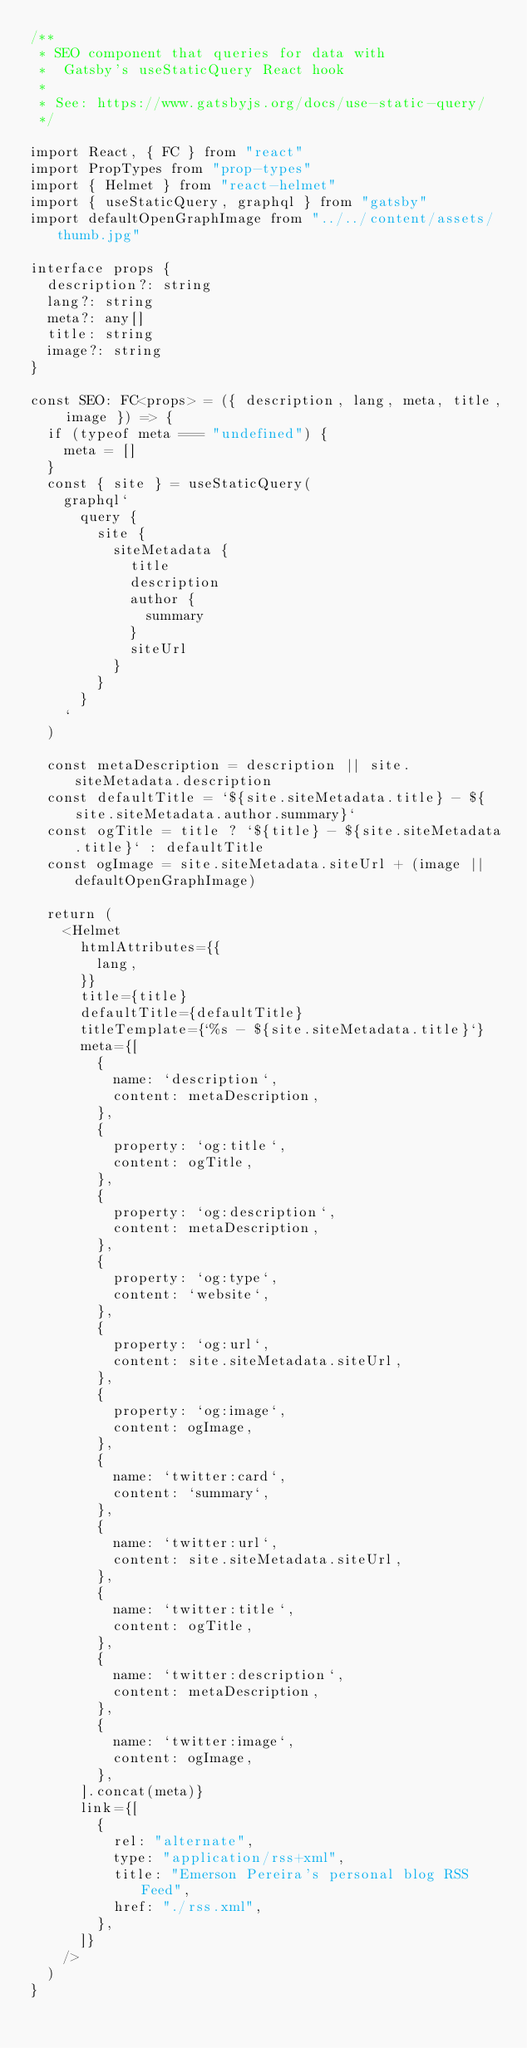<code> <loc_0><loc_0><loc_500><loc_500><_TypeScript_>/**
 * SEO component that queries for data with
 *  Gatsby's useStaticQuery React hook
 *
 * See: https://www.gatsbyjs.org/docs/use-static-query/
 */

import React, { FC } from "react"
import PropTypes from "prop-types"
import { Helmet } from "react-helmet"
import { useStaticQuery, graphql } from "gatsby"
import defaultOpenGraphImage from "../../content/assets/thumb.jpg"

interface props {
  description?: string
  lang?: string
  meta?: any[]
  title: string
  image?: string
}

const SEO: FC<props> = ({ description, lang, meta, title, image }) => {
  if (typeof meta === "undefined") {
    meta = []
  }
  const { site } = useStaticQuery(
    graphql`
      query {
        site {
          siteMetadata {
            title
            description
            author {
              summary
            }
            siteUrl
          }
        }
      }
    `
  )

  const metaDescription = description || site.siteMetadata.description
  const defaultTitle = `${site.siteMetadata.title} - ${site.siteMetadata.author.summary}`
  const ogTitle = title ? `${title} - ${site.siteMetadata.title}` : defaultTitle
  const ogImage = site.siteMetadata.siteUrl + (image || defaultOpenGraphImage)

  return (
    <Helmet
      htmlAttributes={{
        lang,
      }}
      title={title}
      defaultTitle={defaultTitle}
      titleTemplate={`%s - ${site.siteMetadata.title}`}
      meta={[
        {
          name: `description`,
          content: metaDescription,
        },
        {
          property: `og:title`,
          content: ogTitle,
        },
        {
          property: `og:description`,
          content: metaDescription,
        },
        {
          property: `og:type`,
          content: `website`,
        },
        {
          property: `og:url`,
          content: site.siteMetadata.siteUrl,
        },
        {
          property: `og:image`,
          content: ogImage,
        },
        {
          name: `twitter:card`,
          content: `summary`,
        },
        {
          name: `twitter:url`,
          content: site.siteMetadata.siteUrl,
        },
        {
          name: `twitter:title`,
          content: ogTitle,
        },
        {
          name: `twitter:description`,
          content: metaDescription,
        },
        {
          name: `twitter:image`,
          content: ogImage,
        },
      ].concat(meta)}
      link={[
        {
          rel: "alternate",
          type: "application/rss+xml",
          title: "Emerson Pereira's personal blog RSS Feed",
          href: "./rss.xml",
        },
      ]}
    />
  )
}
</code> 